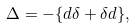<formula> <loc_0><loc_0><loc_500><loc_500>\Delta = - \{ d \delta + \delta d \} ,</formula> 